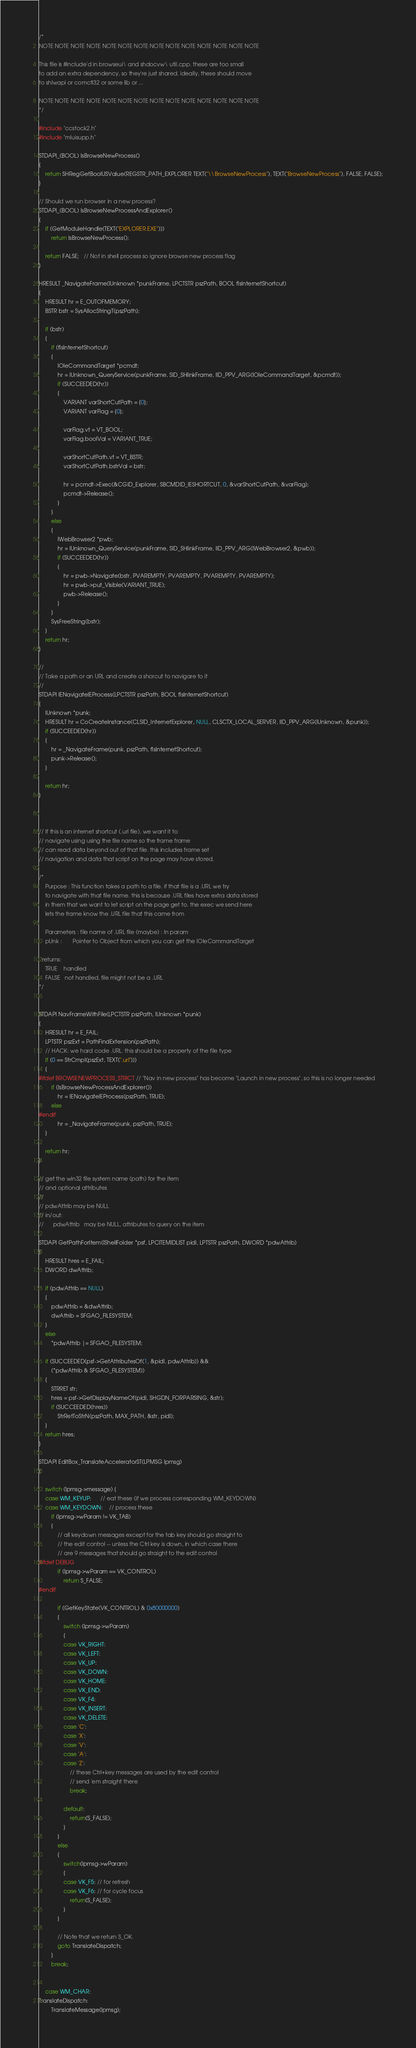<code> <loc_0><loc_0><loc_500><loc_500><_C++_>/*
NOTE NOTE NOTE NOTE NOTE NOTE NOTE NOTE NOTE NOTE NOTE NOTE NOTE NOTE 

This file is #include'd in browseui\ and shdocvw\ util.cpp. these are too small
to add an extra dependency, so they're just shared. ideally, these should move
to shlwapi or comctl32 or some lib or ...

NOTE NOTE NOTE NOTE NOTE NOTE NOTE NOTE NOTE NOTE NOTE NOTE NOTE NOTE 
*/

#include "ccstock2.h"
#include "mluisupp.h"

STDAPI_(BOOL) IsBrowseNewProcess()
{
    return SHRegGetBoolUSValue(REGSTR_PATH_EXPLORER TEXT("\\BrowseNewProcess"), TEXT("BrowseNewProcess"), FALSE, FALSE);
}

// Should we run browser in a new process?
STDAPI_(BOOL) IsBrowseNewProcessAndExplorer()
{
    if (GetModuleHandle(TEXT("EXPLORER.EXE")))
        return IsBrowseNewProcess();

    return FALSE;   // Not in shell process so ignore browse new process flag
}

HRESULT _NavigateFrame(IUnknown *punkFrame, LPCTSTR pszPath, BOOL fIsInternetShortcut)
{
    HRESULT hr = E_OUTOFMEMORY;
    BSTR bstr = SysAllocStringT(pszPath);

    if (bstr)
    {
        if (fIsInternetShortcut)
        {
            IOleCommandTarget *pcmdt;
            hr = IUnknown_QueryService(punkFrame, SID_SHlinkFrame, IID_PPV_ARG(IOleCommandTarget, &pcmdt));
            if (SUCCEEDED(hr))
            {
                VARIANT varShortCutPath = {0};
                VARIANT varFlag = {0};

                varFlag.vt = VT_BOOL;
                varFlag.boolVal = VARIANT_TRUE;

                varShortCutPath.vt = VT_BSTR;
                varShortCutPath.bstrVal = bstr;

                hr = pcmdt->Exec(&CGID_Explorer, SBCMDID_IESHORTCUT, 0, &varShortCutPath, &varFlag);                
                pcmdt->Release();
            }
        }
        else
        {
            IWebBrowser2 *pwb;
            hr = IUnknown_QueryService(punkFrame, SID_SHlinkFrame, IID_PPV_ARG(IWebBrowser2, &pwb));
            if (SUCCEEDED(hr))
            {
                hr = pwb->Navigate(bstr, PVAREMPTY, PVAREMPTY, PVAREMPTY, PVAREMPTY);
                hr = pwb->put_Visible(VARIANT_TRUE);
                pwb->Release();
            }
        }
        SysFreeString(bstr);
    }
    return hr;
}

//
// Take a path or an URL and create a shorcut to navigare to it
//
STDAPI IENavigateIEProcess(LPCTSTR pszPath, BOOL fIsInternetShortcut)
{
    IUnknown *punk;
    HRESULT hr = CoCreateInstance(CLSID_InternetExplorer, NULL, CLSCTX_LOCAL_SERVER, IID_PPV_ARG(IUnknown, &punk));
    if (SUCCEEDED(hr))
    {
        hr = _NavigateFrame(punk, pszPath, fIsInternetShortcut);
        punk->Release();
    }
    
    return hr;
}
        


// If this is an internet shortcut (.url file), we want it to
// navigate using using the file name so the frame frame
// can read data beyond out of that file. this includes frame set
// navigation and data that script on the page may have stored.

/*
    Purpose : This function takes a path to a file. if that file is a .URL we try
    to navigate with that file name. this is because .URL files have extra data stored
    in them that we want to let script on the page get to. the exec we send here
    lets the frame know the .URL file that this came from

    Parameters : file name of .URL file (maybe) : In param
    pUnk :       Pointer to Object from which you can get the IOleCommandTarget

  returns:
    TRUE    handled
    FALSE   not handled, file might not be a .URL
*/


STDAPI NavFrameWithFile(LPCTSTR pszPath, IUnknown *punk)
{
    HRESULT hr = E_FAIL;
    LPTSTR pszExt = PathFindExtension(pszPath);
    // HACK: we hard code .URL. this should be a property of the file type
    if (0 == StrCmpI(pszExt, TEXT(".url")))
    {
#ifdef BROWSENEWPROCESS_STRICT // "Nav in new process" has become "Launch in new process", so this is no longer needed
        if (IsBrowseNewProcessAndExplorer())
            hr = IENavigateIEProcess(pszPath, TRUE);
        else
#endif
            hr = _NavigateFrame(punk, pszPath, TRUE);
    }

    return hr;
}

// get the win32 file system name (path) for the item
// and optional attributes
//
// pdwAttrib may be NULL
// in/out:
//      pdwAttrib   may be NULL, attributes to query on the item

STDAPI GetPathForItem(IShellFolder *psf, LPCITEMIDLIST pidl, LPTSTR pszPath, DWORD *pdwAttrib)
{
    HRESULT hres = E_FAIL;
    DWORD dwAttrib;

    if (pdwAttrib == NULL)
    {
        pdwAttrib = &dwAttrib;
        dwAttrib = SFGAO_FILESYSTEM;
    }
    else
        *pdwAttrib |= SFGAO_FILESYSTEM;

    if (SUCCEEDED(psf->GetAttributesOf(1, &pidl, pdwAttrib)) &&
        (*pdwAttrib & SFGAO_FILESYSTEM))
    {
        STRRET str;
        hres = psf->GetDisplayNameOf(pidl, SHGDN_FORPARSING, &str);
        if (SUCCEEDED(hres))
            StrRetToStrN(pszPath, MAX_PATH, &str, pidl);
    }
    return hres;
}

STDAPI EditBox_TranslateAcceleratorST(LPMSG lpmsg)
{

    switch (lpmsg->message) {
    case WM_KEYUP:      // eat these (if we process corresponding WM_KEYDOWN)
    case WM_KEYDOWN:    // process these
        if (lpmsg->wParam != VK_TAB)
        {
            // all keydown messages except for the tab key should go straight to
            // the edit control -- unless the Ctrl key is down, in which case there
            // are 9 messages that should go straight to the edit control
#ifdef DEBUG
            if (lpmsg->wParam == VK_CONTROL)
                return S_FALSE;
#endif

            if (GetKeyState(VK_CONTROL) & 0x80000000)
            {
                switch (lpmsg->wParam)
                {
                case VK_RIGHT:
                case VK_LEFT:
                case VK_UP:
                case VK_DOWN:
                case VK_HOME:
                case VK_END:
                case VK_F4:
                case VK_INSERT:
                case VK_DELETE:
                case 'C':
                case 'X':
                case 'V':
                case 'A':
                case 'Z':
                    // these Ctrl+key messages are used by the edit control
                    // send 'em straight there
                    break;

                default:
                    return(S_FALSE);
                }
            }
            else
            {
                switch(lpmsg->wParam)
                {
                case VK_F5: // for refresh
                case VK_F6: // for cycle focus
                    return(S_FALSE);
                }
            }

            // Note that we return S_OK.
            goto TranslateDispatch;
        }
        break;


    case WM_CHAR:
TranslateDispatch:
        TranslateMessage(lpmsg);</code> 